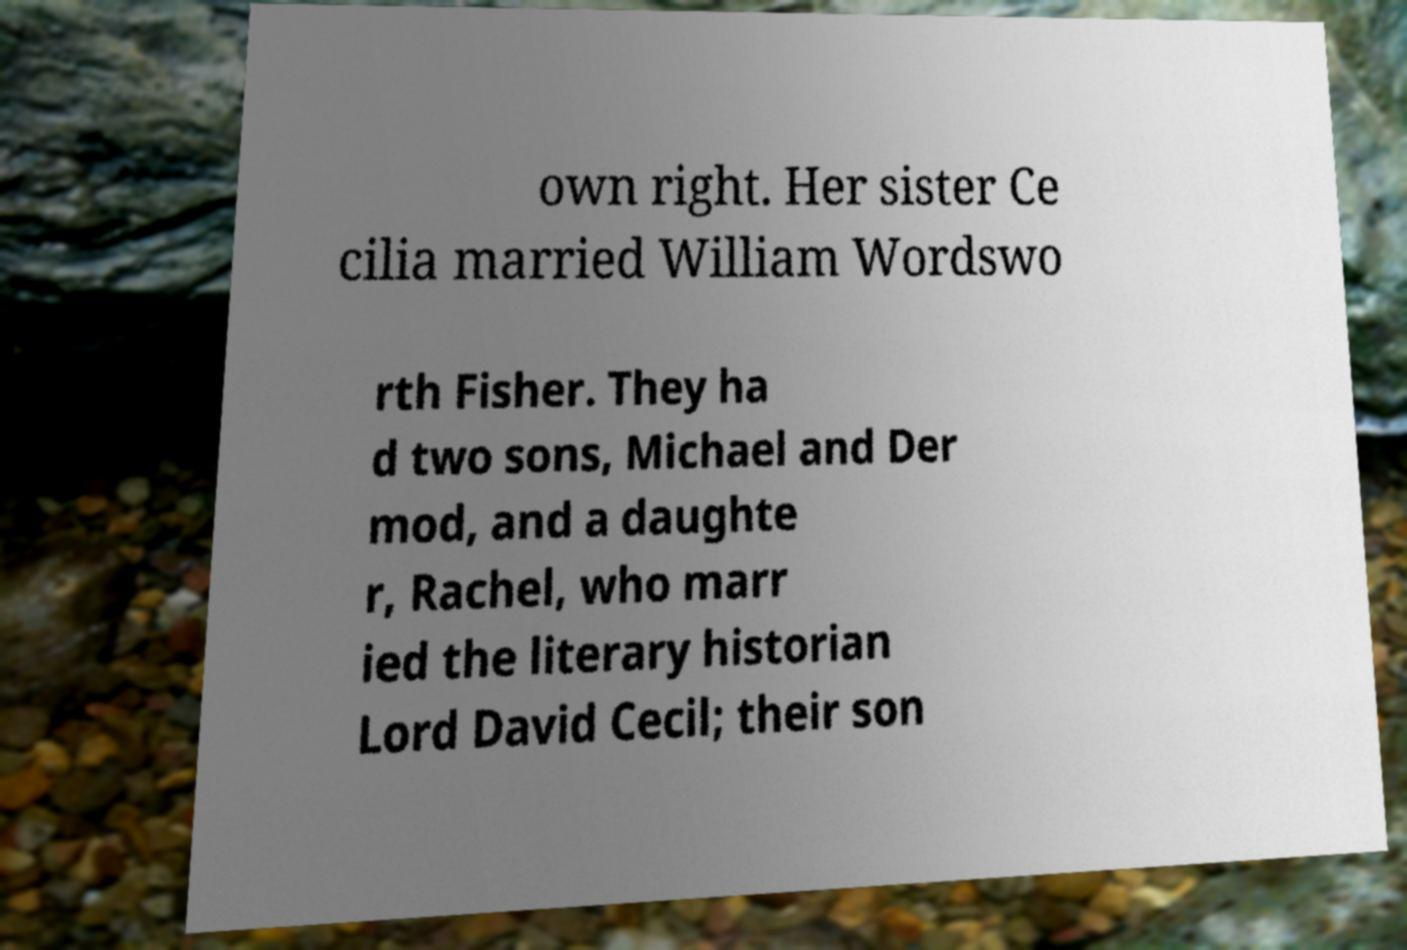Please read and relay the text visible in this image. What does it say? own right. Her sister Ce cilia married William Wordswo rth Fisher. They ha d two sons, Michael and Der mod, and a daughte r, Rachel, who marr ied the literary historian Lord David Cecil; their son 